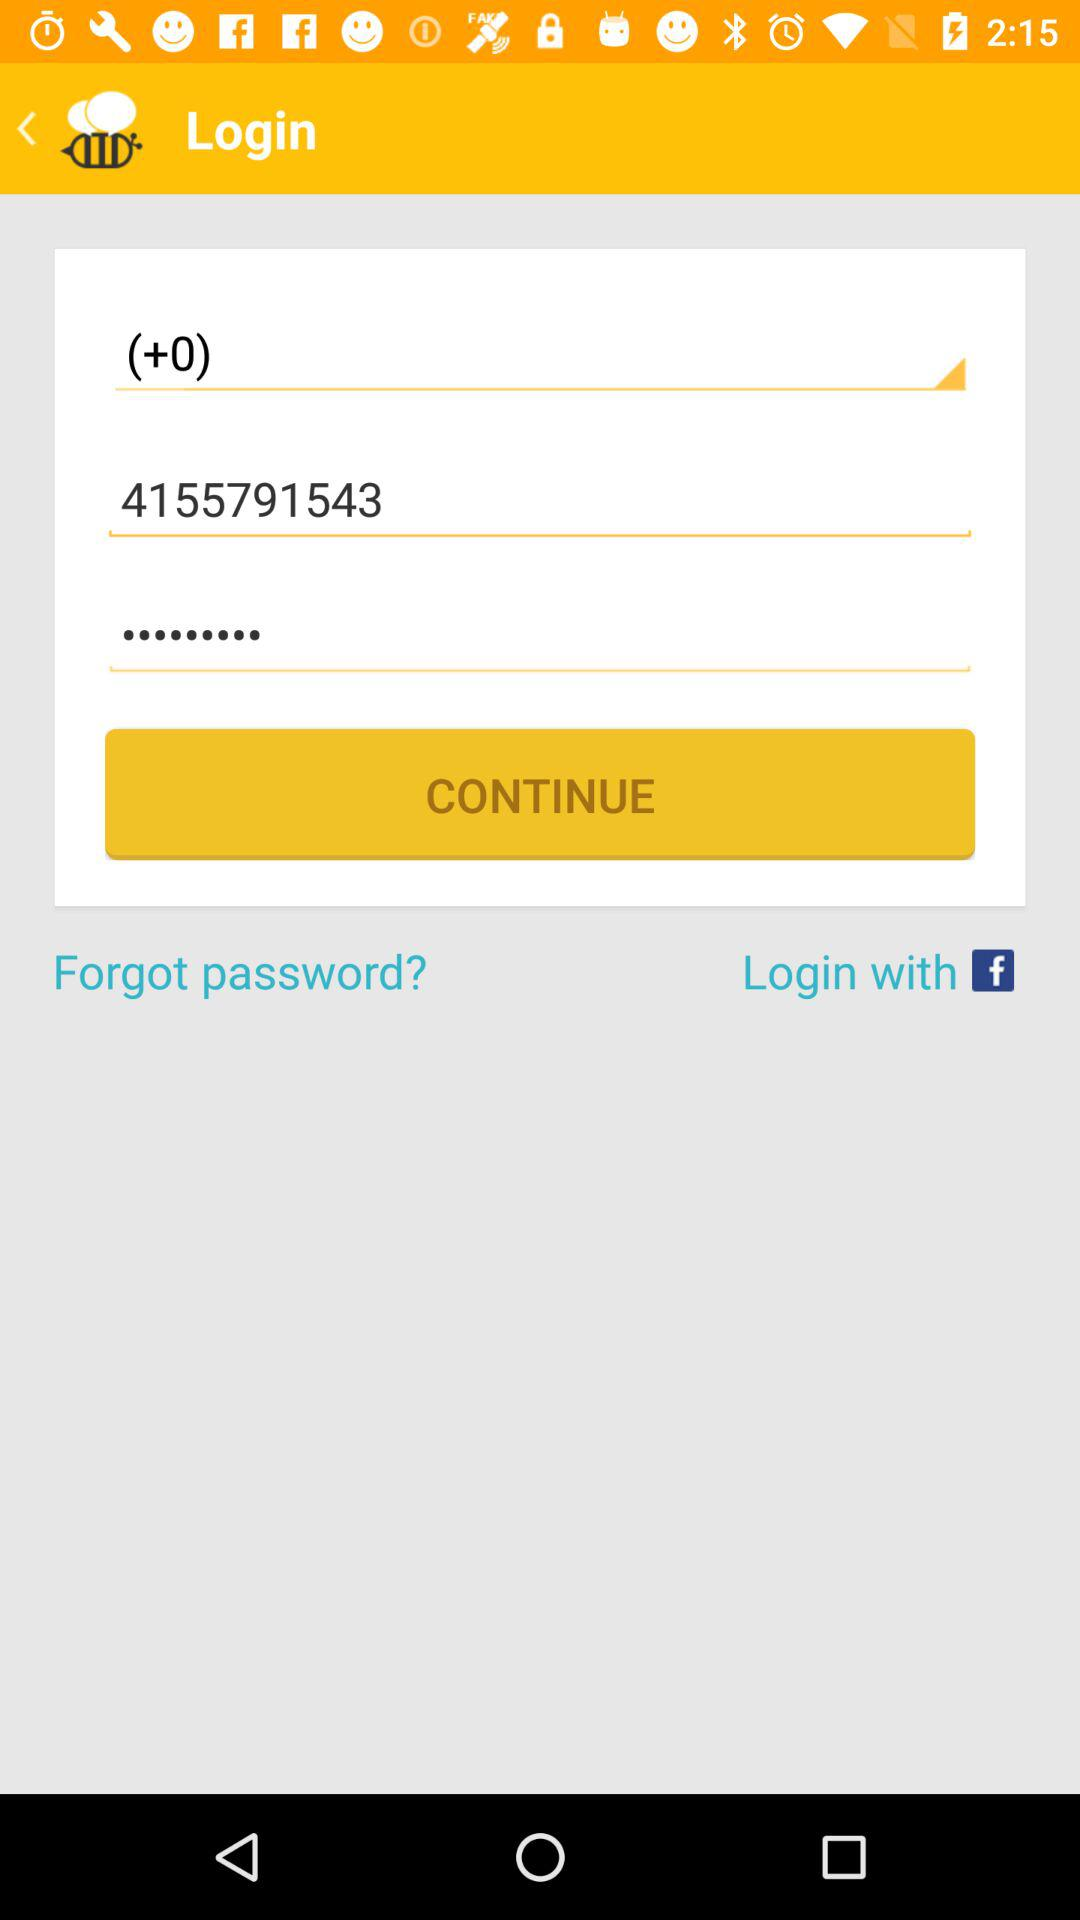What account can I use to log in? You can use "Facebook" to log in. 